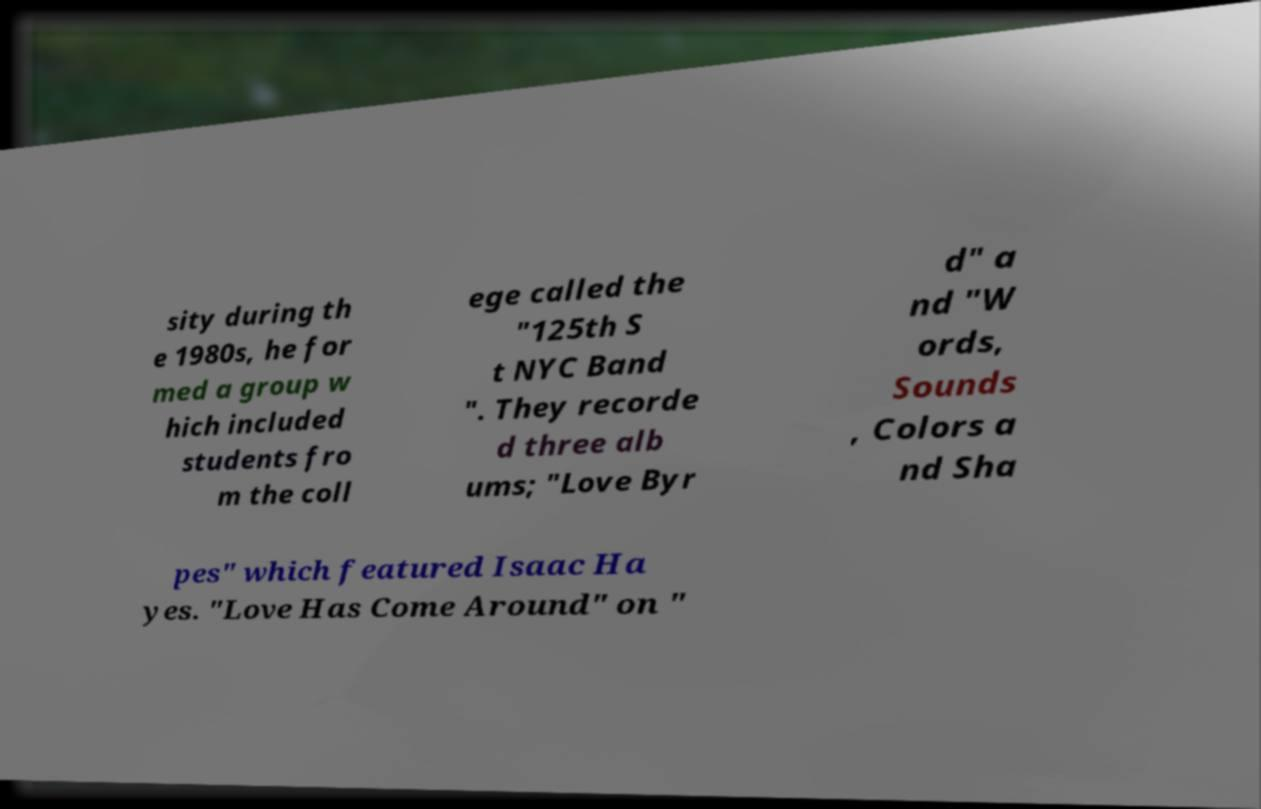Please read and relay the text visible in this image. What does it say? sity during th e 1980s, he for med a group w hich included students fro m the coll ege called the "125th S t NYC Band ". They recorde d three alb ums; "Love Byr d" a nd "W ords, Sounds , Colors a nd Sha pes" which featured Isaac Ha yes. "Love Has Come Around" on " 